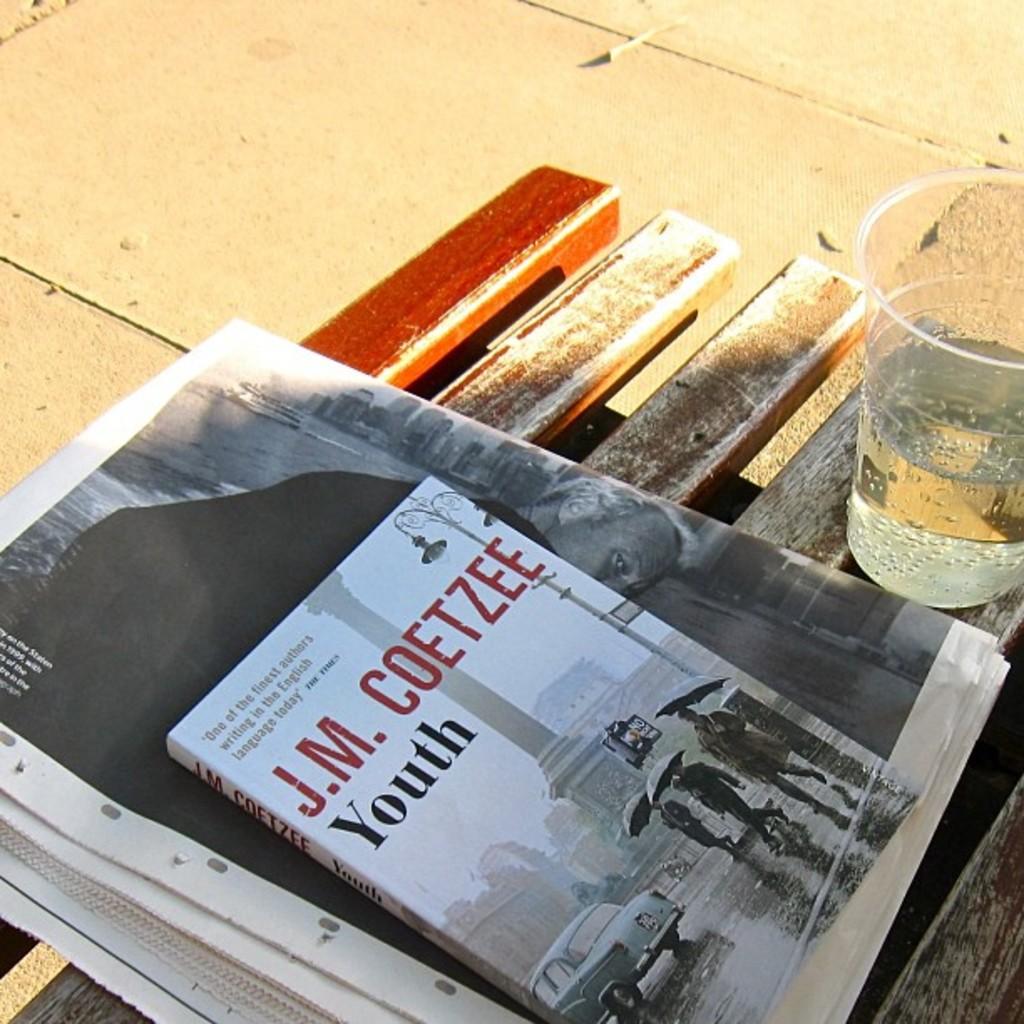Who wrote "youth"?
Give a very brief answer. J.m. coetzee. What is the name of the book?
Your answer should be compact. Youth. 